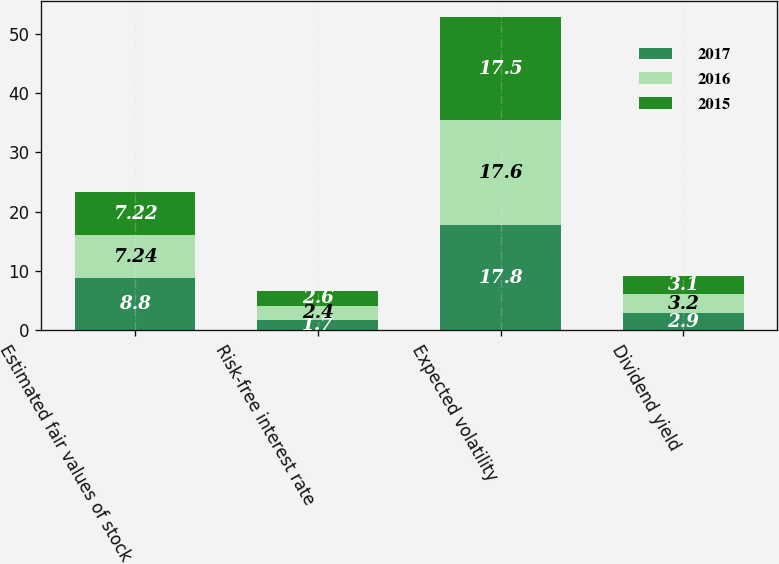Convert chart to OTSL. <chart><loc_0><loc_0><loc_500><loc_500><stacked_bar_chart><ecel><fcel>Estimated fair values of stock<fcel>Risk-free interest rate<fcel>Expected volatility<fcel>Dividend yield<nl><fcel>2017<fcel>8.8<fcel>1.7<fcel>17.8<fcel>2.9<nl><fcel>2016<fcel>7.24<fcel>2.4<fcel>17.6<fcel>3.2<nl><fcel>2015<fcel>7.22<fcel>2.6<fcel>17.5<fcel>3.1<nl></chart> 